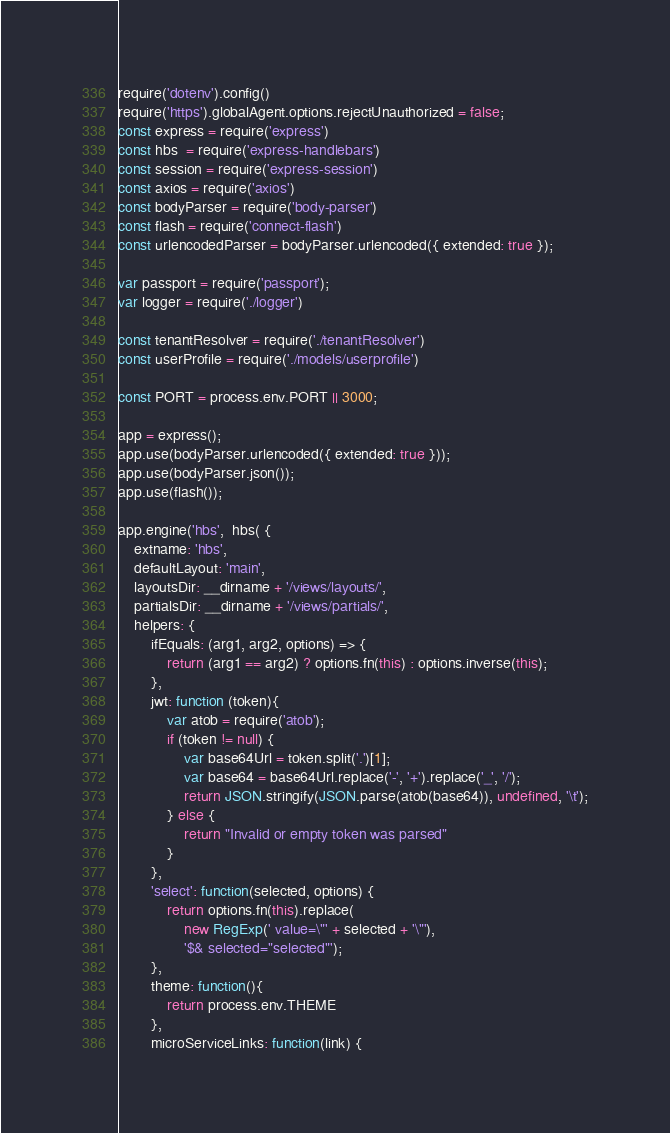<code> <loc_0><loc_0><loc_500><loc_500><_JavaScript_>require('dotenv').config()
require('https').globalAgent.options.rejectUnauthorized = false;
const express = require('express')
const hbs  = require('express-handlebars')
const session = require('express-session')
const axios = require('axios')
const bodyParser = require('body-parser')
const flash = require('connect-flash')
const urlencodedParser = bodyParser.urlencoded({ extended: true });

var passport = require('passport');
var logger = require('./logger')

const tenantResolver = require('./tenantResolver')
const userProfile = require('./models/userprofile')

const PORT = process.env.PORT || 3000;

app = express();
app.use(bodyParser.urlencoded({ extended: true }));
app.use(bodyParser.json());
app.use(flash());

app.engine('hbs',  hbs( { 
    extname: 'hbs', 
    defaultLayout: 'main', 
    layoutsDir: __dirname + '/views/layouts/',
    partialsDir: __dirname + '/views/partials/',
    helpers: {
        ifEquals: (arg1, arg2, options) => {
            return (arg1 == arg2) ? options.fn(this) : options.inverse(this);
        },
        jwt: function (token){
            var atob = require('atob');
            if (token != null) {
                var base64Url = token.split('.')[1];
                var base64 = base64Url.replace('-', '+').replace('_', '/');
                return JSON.stringify(JSON.parse(atob(base64)), undefined, '\t');
            } else {
                return "Invalid or empty token was parsed"
            }
        },
        'select': function(selected, options) {
            return options.fn(this).replace(
                new RegExp(' value=\"' + selected + '\"'),
                '$& selected="selected"');
        },
        theme: function(){
            return process.env.THEME
        },
        microServiceLinks: function(link) {</code> 